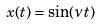<formula> <loc_0><loc_0><loc_500><loc_500>x ( t ) = \sin ( \nu t )</formula> 